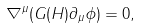Convert formula to latex. <formula><loc_0><loc_0><loc_500><loc_500>\nabla ^ { \mu } ( G ( H ) \partial _ { \mu } \phi ) = 0 ,</formula> 